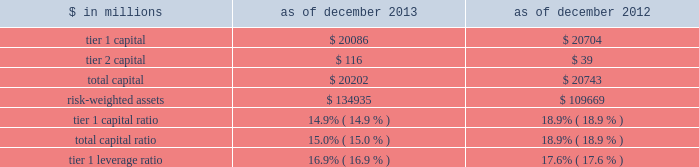Notes to consolidated financial statements under the regulatory framework for prompt corrective action applicable to gs bank usa , in order to meet the quantitative requirements for being a 201cwell-capitalized 201d depository institution , gs bank usa is required to maintain a tier 1 capital ratio of at least 6% ( 6 % ) , a total capital ratio of at least 10% ( 10 % ) and a tier 1 leverage ratio of at least 5% ( 5 % ) .
Gs bank usa agreed with the federal reserve board to maintain minimum capital ratios in excess of these 201cwell- capitalized 201d levels .
Accordingly , for a period of time , gs bank usa is expected to maintain a tier 1 capital ratio of at least 8% ( 8 % ) , a total capital ratio of at least 11% ( 11 % ) and a tier 1 leverage ratio of at least 6% ( 6 % ) .
As noted in the table below , gs bank usa was in compliance with these minimum capital requirements as of december 2013 and december 2012 .
The table below presents information regarding gs bank usa 2019s regulatory capital ratios under basel i , as implemented by the federal reserve board .
The information as of december 2013 reflects the revised market risk regulatory capital requirements , which became effective on january 1 , 2013 .
These changes resulted in increased regulatory capital requirements for market risk .
The information as of december 2012 is prior to the implementation of these revised market risk regulatory capital requirements. .
The revised capital framework described above is also applicable to gs bank usa , which is an advanced approach banking organization under this framework .
Gs bank usa has also been informed by the federal reserve board that it has completed a satisfactory parallel run , as required of advanced approach banking organizations under the revised capital framework , and therefore changes to its calculations of rwas will take effect beginning with the second quarter of 2014 .
Under the revised capital framework , as of january 1 , 2014 , gs bank usa became subject to a new minimum cet1 ratio requirement of 4% ( 4 % ) , increasing to 4.5% ( 4.5 % ) in 2015 .
In addition , the revised capital framework changes the standards for 201cwell-capitalized 201d status under prompt corrective action regulations beginning january 1 , 2015 by , among other things , introducing a cet1 ratio requirement of 6.5% ( 6.5 % ) and increasing the tier 1 capital ratio requirement from 6% ( 6 % ) to 8% ( 8 % ) .
In addition , commencing january 1 , 2018 , advanced approach banking organizations must have a supplementary leverage ratio of 3% ( 3 % ) or greater .
The basel committee published its final guidelines for calculating incremental capital requirements for domestic systemically important banking institutions ( d-sibs ) .
These guidelines are complementary to the framework outlined above for g-sibs .
The impact of these guidelines on the regulatory capital requirements of gs bank usa will depend on how they are implemented by the banking regulators in the united states .
The deposits of gs bank usa are insured by the fdic to the extent provided by law .
The federal reserve board requires depository institutions to maintain cash reserves with a federal reserve bank .
The amount deposited by the firm 2019s depository institution held at the federal reserve bank was approximately $ 50.39 billion and $ 58.67 billion as of december 2013 and december 2012 , respectively , which exceeded required reserve amounts by $ 50.29 billion and $ 58.59 billion as of december 2013 and december 2012 , respectively .
Transactions between gs bank usa and its subsidiaries and group inc .
And its subsidiaries and affiliates ( other than , generally , subsidiaries of gs bank usa ) are regulated by the federal reserve board .
These regulations generally limit the types and amounts of transactions ( including credit extensions from gs bank usa ) that may take place and generally require those transactions to be on market terms or better to gs bank usa .
The firm 2019s principal non-u.s .
Bank subsidiary , gsib , is a wholly-owned credit institution , regulated by the prudential regulation authority ( pra ) and the financial conduct authority ( fca ) and is subject to minimum capital requirements .
As of december 2013 and december 2012 , gsib was in compliance with all regulatory capital requirements .
Goldman sachs 2013 annual report 193 .
Under the revised capital framework what was the change in percentage points to the new minimum cet1 ratio requirement in 2015? 
Computations: (4.5% - 4%)
Answer: 0.005. 